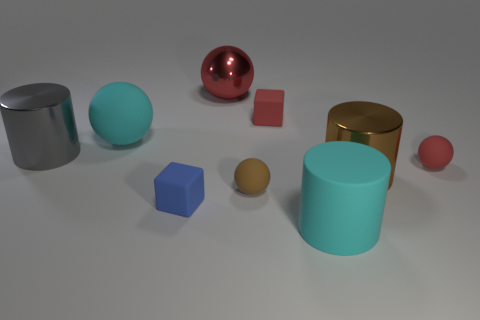How many big rubber cylinders are the same color as the big rubber ball?
Give a very brief answer. 1. What shape is the big cyan rubber thing that is in front of the small matte thing that is in front of the brown matte object?
Provide a succinct answer. Cylinder. There is a large brown cylinder; how many objects are behind it?
Your answer should be very brief. 5. What is the color of the big ball that is the same material as the large gray object?
Your response must be concise. Red. There is a cyan matte cylinder; does it have the same size as the metallic cylinder that is to the left of the red block?
Offer a very short reply. Yes. What size is the rubber sphere to the right of the tiny rubber cube behind the small rubber ball that is behind the tiny brown matte ball?
Provide a succinct answer. Small. What number of metallic things are either brown cubes or cyan spheres?
Give a very brief answer. 0. There is a large rubber object that is in front of the large rubber sphere; what is its color?
Give a very brief answer. Cyan. There is a brown metal object that is the same size as the cyan cylinder; what is its shape?
Ensure brevity in your answer.  Cylinder. Do the matte cylinder and the rubber ball that is behind the gray cylinder have the same color?
Make the answer very short. Yes. 